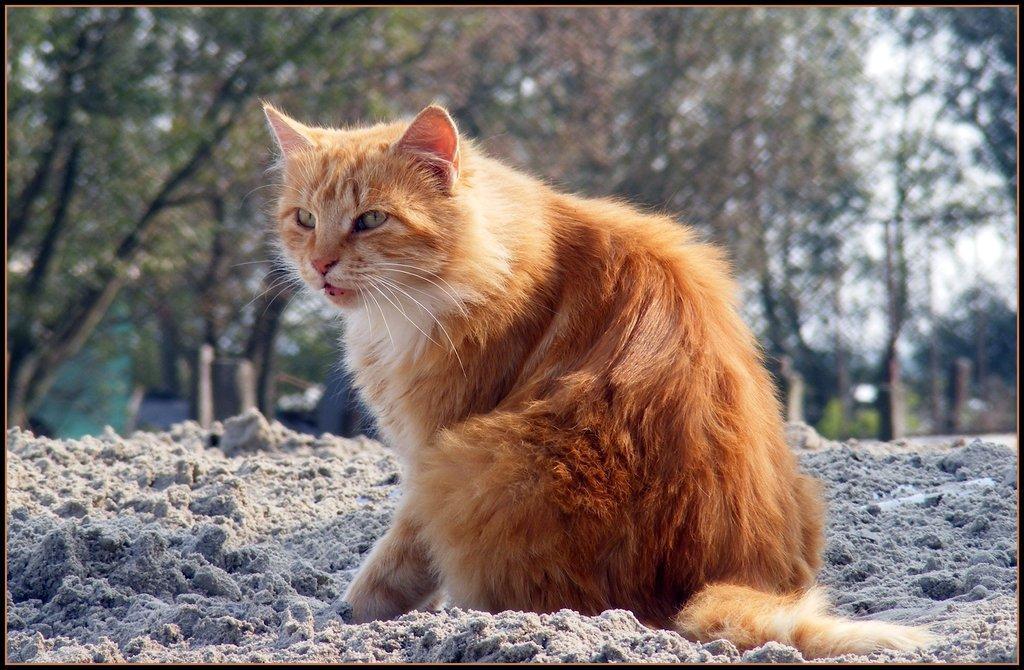In one or two sentences, can you explain what this image depicts? In this image I see a cat over here which is of white and cream in color and I see the sand. In the background I see number of trees. 